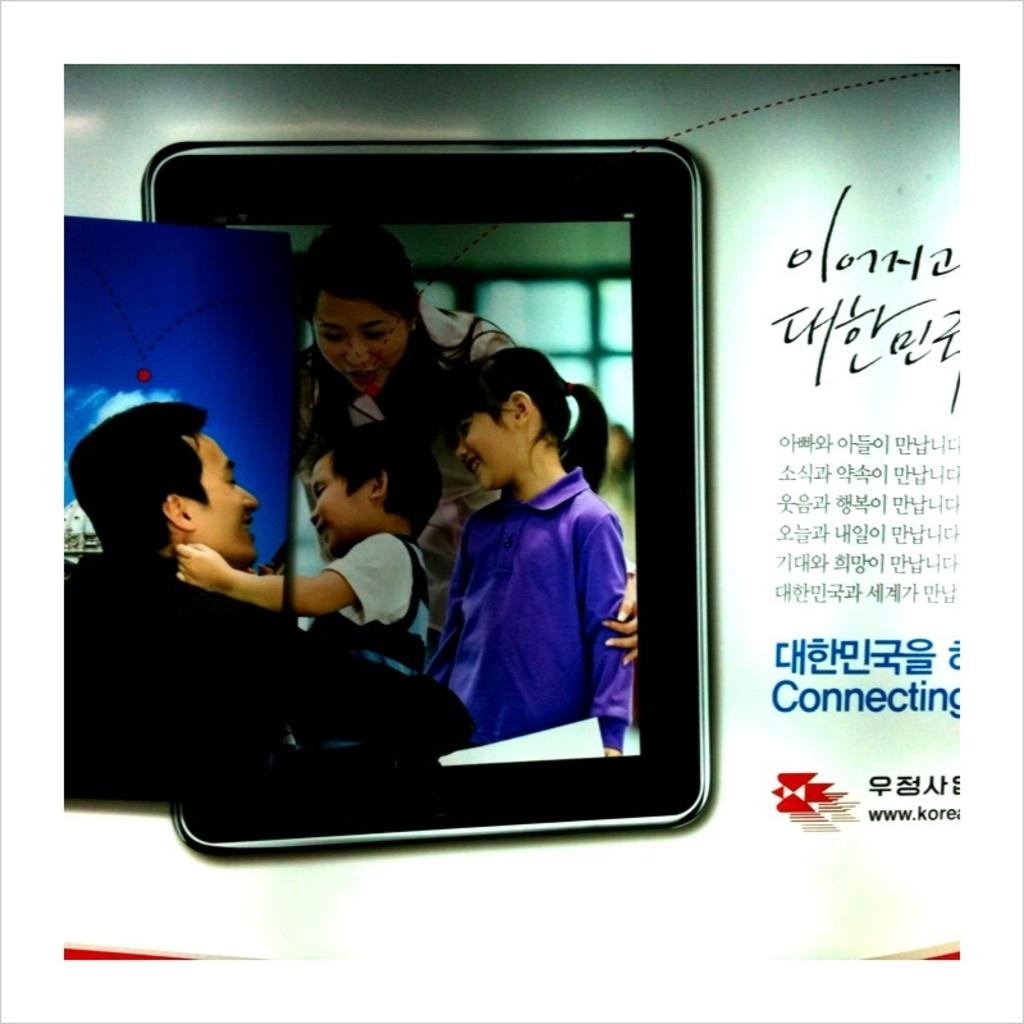What type of visual is depicted in the image? The image is a poster. Who or what can be seen in the poster? There are people in the image. What is the facial expression of the people in the poster? The people are smiling. Where is the text located on the poster? The text is on the right side of the image. What flavor of ice cream is being requested by the people in the image? There is no mention of ice cream or a request in the image, so it cannot be determined. 